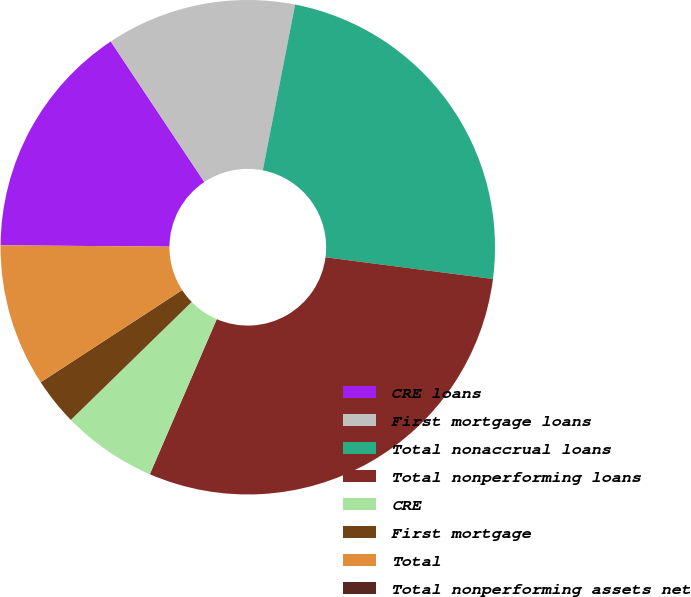Convert chart. <chart><loc_0><loc_0><loc_500><loc_500><pie_chart><fcel>CRE loans<fcel>First mortgage loans<fcel>Total nonaccrual loans<fcel>Total nonperforming loans<fcel>CRE<fcel>First mortgage<fcel>Total<fcel>Total nonperforming assets net<nl><fcel>15.53%<fcel>12.42%<fcel>23.99%<fcel>29.44%<fcel>6.21%<fcel>3.11%<fcel>9.32%<fcel>0.0%<nl></chart> 